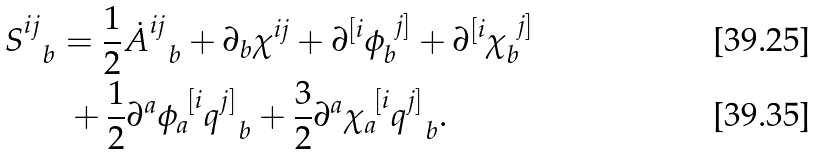<formula> <loc_0><loc_0><loc_500><loc_500>S ^ { i j } _ { \ \ b } & = \frac { 1 } { 2 } { \dot { A } ^ { i j } _ { \ \ b } } + \partial _ { b } \chi ^ { i j } + \partial ^ { [ i } \phi _ { b } ^ { \ j ] } + \partial ^ { [ i } \chi _ { b } ^ { \ j ] } \\ & \ + \frac { 1 } { 2 } \partial ^ { a } \phi _ { a } ^ { \ [ i } q ^ { j ] } _ { \ \ b } + \frac { 3 } { 2 } \partial ^ { a } \chi _ { a } ^ { \ [ i } q ^ { j ] } _ { \ \ b } .</formula> 